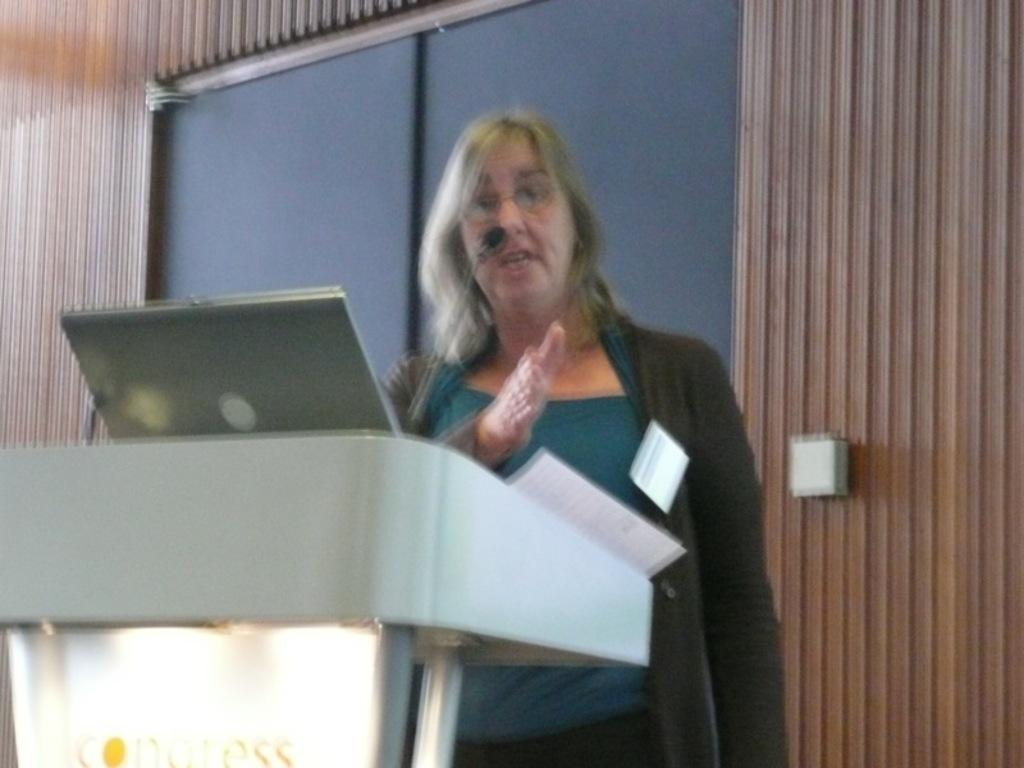What is the woman doing in the image? The woman is standing in front of the podium. What is on the podium with the woman? There is a laptop and a microphone on the podium. What can be seen in the background of the image? There is a window visible in the background. Are there any fairies flying around the woman in the image? No, there are no fairies present in the image. Can you see any mice scurrying across the podium in the image? No, there are no mice visible in the image. 